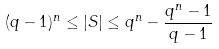<formula> <loc_0><loc_0><loc_500><loc_500>( q - 1 ) ^ { n } \leq | S | \leq q ^ { n } - \frac { q ^ { n } - 1 } { q - 1 }</formula> 